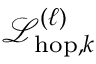Convert formula to latex. <formula><loc_0><loc_0><loc_500><loc_500>\mathcal { L } _ { h o p , k } ^ { ( \ell ) }</formula> 